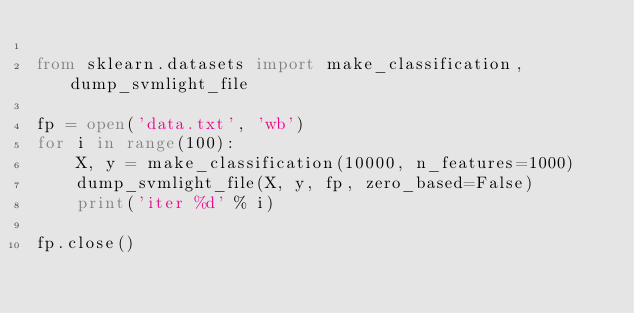<code> <loc_0><loc_0><loc_500><loc_500><_Python_>
from sklearn.datasets import make_classification, dump_svmlight_file

fp = open('data.txt', 'wb')
for i in range(100):
	X, y = make_classification(10000, n_features=1000)
	dump_svmlight_file(X, y, fp, zero_based=False)
	print('iter %d' % i)

fp.close()
</code> 